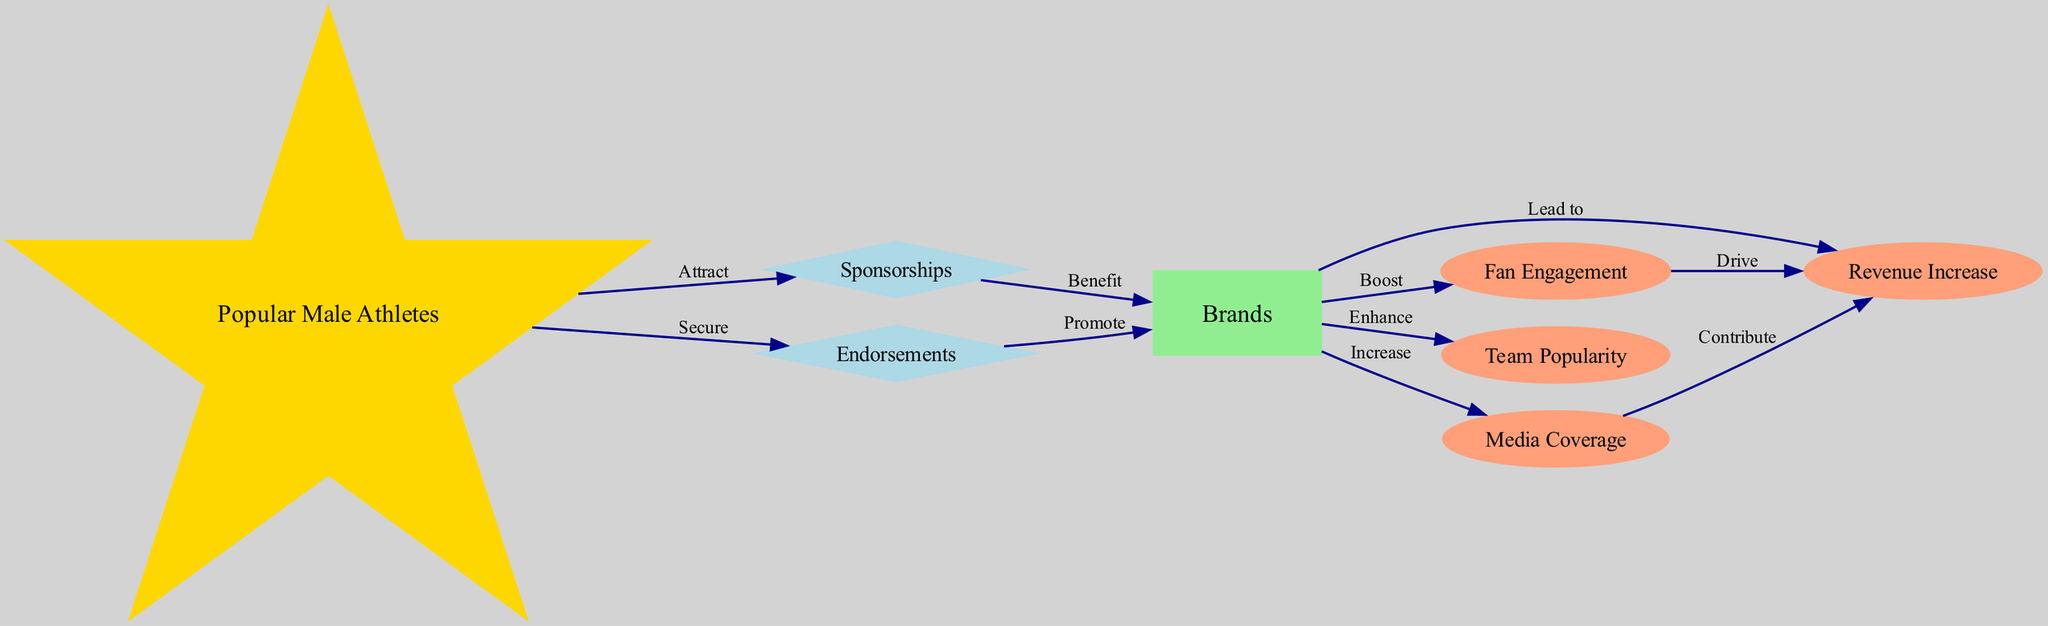What is the central theme of the diagram? The diagram illustrates the flow of sponsorships and endorsements involving popular male athletes and how they impact brands. This is presented in a food chain structure, showing the sequence of relationships and outcomes.
Answer: Sponsorships and endorsements How many nodes are there in total? The diagram lists eight distinct nodes: popular male athletes, brands, sponsorships, endorsements, revenue increase, fan engagement, team popularity, and media coverage. Adding them up gives a total of eight nodes.
Answer: 8 What shape is used for the node representing brands? In the diagram, the node for brands is represented as a rectangle, which is a standard shape used to depict entities in a flowchart or food chain diagram.
Answer: Rectangle Which node comes directly after endorsements? According to the relationships in the diagram, endorsements promote brands, indicating that the node brands is the direct successor to endorsements.
Answer: Brands What effect do brands have on revenue increase? The diagram shows that brands lead to revenue increase, demonstrating a direct beneficial relationship where brands contribute to an increase in revenue.
Answer: Lead to How do fan engagement and media coverage contribute to revenue increase? Both fan engagement drives revenue increase and media coverage contributes to revenue increase, showcasing that these factors enhance ways to generate revenue. Thus, they interact stepwise within the chain to result in increased revenue.
Answer: Drive & Contribute Which node is influenced by sponsorships? The brands node is directly influenced by sponsorships, as seen in the diagram's flow, where sponsorships benefit brands.
Answer: Brands What impacts an increase in team popularity? Brands enhance team popularity, per the diagram. Therefore, brands play a critical role in raising the popularity of the teams associated with the male athletes.
Answer: Enhance 